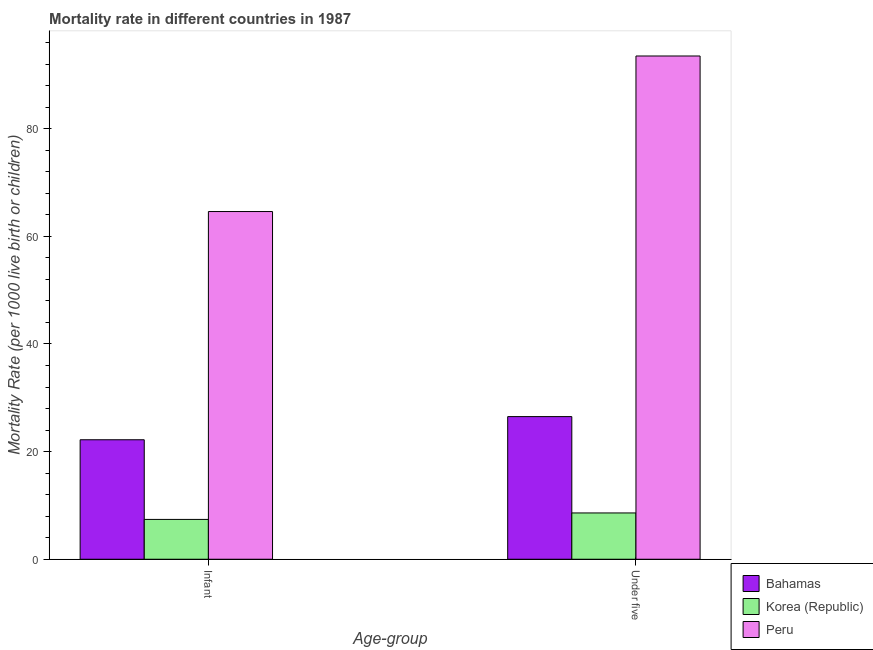Are the number of bars per tick equal to the number of legend labels?
Ensure brevity in your answer.  Yes. How many bars are there on the 1st tick from the left?
Your answer should be very brief. 3. What is the label of the 2nd group of bars from the left?
Keep it short and to the point. Under five. What is the infant mortality rate in Peru?
Your answer should be very brief. 64.6. Across all countries, what is the maximum infant mortality rate?
Make the answer very short. 64.6. In which country was the under-5 mortality rate maximum?
Ensure brevity in your answer.  Peru. In which country was the under-5 mortality rate minimum?
Your answer should be compact. Korea (Republic). What is the total infant mortality rate in the graph?
Provide a short and direct response. 94.2. What is the difference between the under-5 mortality rate in Bahamas and that in Peru?
Ensure brevity in your answer.  -67. What is the difference between the under-5 mortality rate in Korea (Republic) and the infant mortality rate in Bahamas?
Give a very brief answer. -13.6. What is the average infant mortality rate per country?
Keep it short and to the point. 31.4. What is the difference between the infant mortality rate and under-5 mortality rate in Korea (Republic)?
Your response must be concise. -1.2. In how many countries, is the infant mortality rate greater than 68 ?
Make the answer very short. 0. What is the ratio of the infant mortality rate in Peru to that in Bahamas?
Your answer should be very brief. 2.91. Is the under-5 mortality rate in Bahamas less than that in Korea (Republic)?
Offer a terse response. No. In how many countries, is the under-5 mortality rate greater than the average under-5 mortality rate taken over all countries?
Your answer should be compact. 1. What does the 2nd bar from the right in Under five represents?
Your answer should be compact. Korea (Republic). How many bars are there?
Offer a very short reply. 6. Are all the bars in the graph horizontal?
Ensure brevity in your answer.  No. How many countries are there in the graph?
Make the answer very short. 3. Does the graph contain grids?
Make the answer very short. No. How are the legend labels stacked?
Give a very brief answer. Vertical. What is the title of the graph?
Offer a terse response. Mortality rate in different countries in 1987. Does "Iceland" appear as one of the legend labels in the graph?
Make the answer very short. No. What is the label or title of the X-axis?
Ensure brevity in your answer.  Age-group. What is the label or title of the Y-axis?
Provide a succinct answer. Mortality Rate (per 1000 live birth or children). What is the Mortality Rate (per 1000 live birth or children) in Peru in Infant?
Provide a short and direct response. 64.6. What is the Mortality Rate (per 1000 live birth or children) of Peru in Under five?
Provide a succinct answer. 93.5. Across all Age-group, what is the maximum Mortality Rate (per 1000 live birth or children) of Korea (Republic)?
Your answer should be very brief. 8.6. Across all Age-group, what is the maximum Mortality Rate (per 1000 live birth or children) in Peru?
Your answer should be compact. 93.5. Across all Age-group, what is the minimum Mortality Rate (per 1000 live birth or children) of Peru?
Provide a succinct answer. 64.6. What is the total Mortality Rate (per 1000 live birth or children) in Bahamas in the graph?
Your answer should be compact. 48.7. What is the total Mortality Rate (per 1000 live birth or children) in Korea (Republic) in the graph?
Your response must be concise. 16. What is the total Mortality Rate (per 1000 live birth or children) of Peru in the graph?
Ensure brevity in your answer.  158.1. What is the difference between the Mortality Rate (per 1000 live birth or children) in Korea (Republic) in Infant and that in Under five?
Your answer should be very brief. -1.2. What is the difference between the Mortality Rate (per 1000 live birth or children) in Peru in Infant and that in Under five?
Make the answer very short. -28.9. What is the difference between the Mortality Rate (per 1000 live birth or children) in Bahamas in Infant and the Mortality Rate (per 1000 live birth or children) in Korea (Republic) in Under five?
Give a very brief answer. 13.6. What is the difference between the Mortality Rate (per 1000 live birth or children) of Bahamas in Infant and the Mortality Rate (per 1000 live birth or children) of Peru in Under five?
Your answer should be very brief. -71.3. What is the difference between the Mortality Rate (per 1000 live birth or children) in Korea (Republic) in Infant and the Mortality Rate (per 1000 live birth or children) in Peru in Under five?
Your response must be concise. -86.1. What is the average Mortality Rate (per 1000 live birth or children) of Bahamas per Age-group?
Offer a terse response. 24.35. What is the average Mortality Rate (per 1000 live birth or children) in Peru per Age-group?
Offer a very short reply. 79.05. What is the difference between the Mortality Rate (per 1000 live birth or children) in Bahamas and Mortality Rate (per 1000 live birth or children) in Korea (Republic) in Infant?
Offer a very short reply. 14.8. What is the difference between the Mortality Rate (per 1000 live birth or children) in Bahamas and Mortality Rate (per 1000 live birth or children) in Peru in Infant?
Offer a terse response. -42.4. What is the difference between the Mortality Rate (per 1000 live birth or children) of Korea (Republic) and Mortality Rate (per 1000 live birth or children) of Peru in Infant?
Make the answer very short. -57.2. What is the difference between the Mortality Rate (per 1000 live birth or children) in Bahamas and Mortality Rate (per 1000 live birth or children) in Korea (Republic) in Under five?
Keep it short and to the point. 17.9. What is the difference between the Mortality Rate (per 1000 live birth or children) in Bahamas and Mortality Rate (per 1000 live birth or children) in Peru in Under five?
Offer a very short reply. -67. What is the difference between the Mortality Rate (per 1000 live birth or children) in Korea (Republic) and Mortality Rate (per 1000 live birth or children) in Peru in Under five?
Keep it short and to the point. -84.9. What is the ratio of the Mortality Rate (per 1000 live birth or children) of Bahamas in Infant to that in Under five?
Offer a very short reply. 0.84. What is the ratio of the Mortality Rate (per 1000 live birth or children) in Korea (Republic) in Infant to that in Under five?
Make the answer very short. 0.86. What is the ratio of the Mortality Rate (per 1000 live birth or children) of Peru in Infant to that in Under five?
Your answer should be compact. 0.69. What is the difference between the highest and the second highest Mortality Rate (per 1000 live birth or children) in Peru?
Offer a very short reply. 28.9. What is the difference between the highest and the lowest Mortality Rate (per 1000 live birth or children) of Bahamas?
Your answer should be compact. 4.3. What is the difference between the highest and the lowest Mortality Rate (per 1000 live birth or children) of Korea (Republic)?
Keep it short and to the point. 1.2. What is the difference between the highest and the lowest Mortality Rate (per 1000 live birth or children) in Peru?
Give a very brief answer. 28.9. 